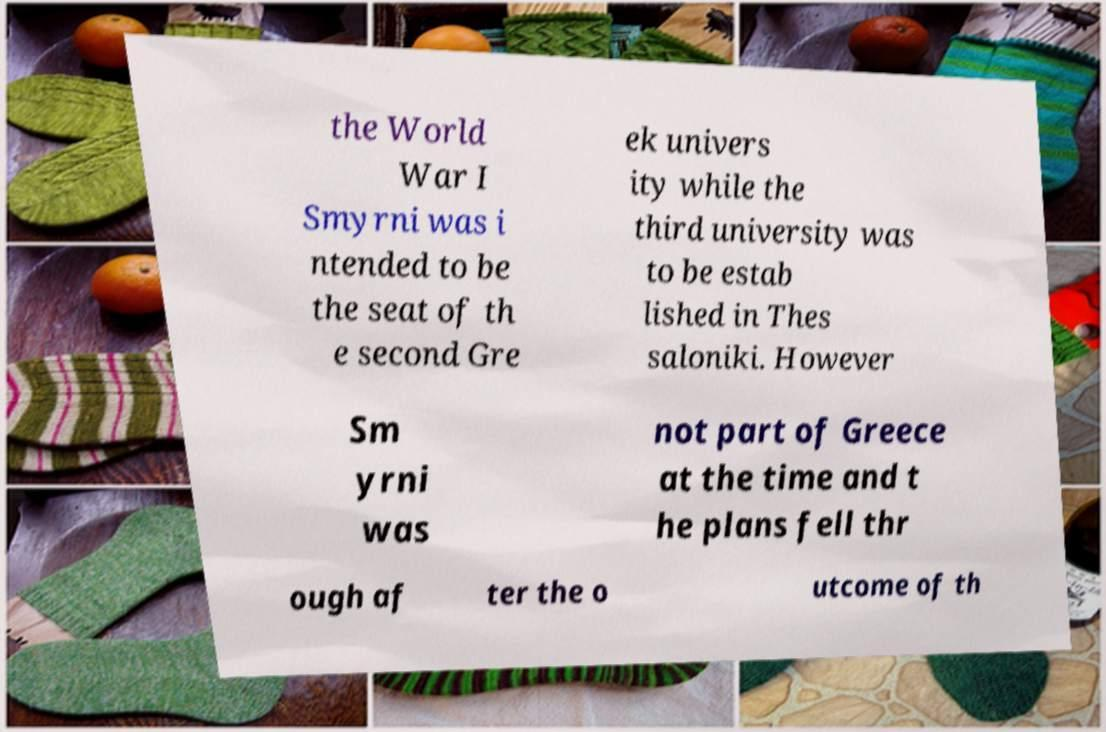I need the written content from this picture converted into text. Can you do that? the World War I Smyrni was i ntended to be the seat of th e second Gre ek univers ity while the third university was to be estab lished in Thes saloniki. However Sm yrni was not part of Greece at the time and t he plans fell thr ough af ter the o utcome of th 